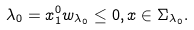<formula> <loc_0><loc_0><loc_500><loc_500>\lambda _ { 0 } = x _ { 1 } ^ { 0 } w _ { \lambda _ { 0 } } \leq 0 , x \in \Sigma _ { \lambda _ { 0 } } . \quad</formula> 